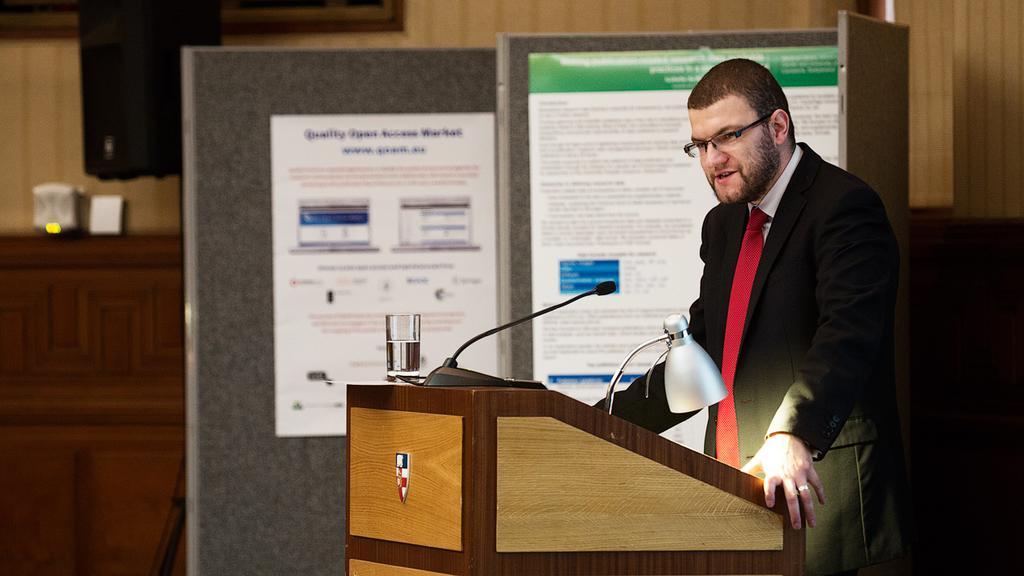Can you describe this image briefly? In this image there is a podium in which a lamp, and mike are attached to it and glass containing of water and there is a man standing and talking in a microphone and at the back ground there are 2 hoarding and a speaker. 